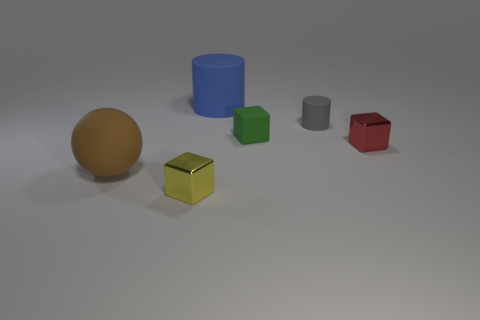Add 2 shiny cubes. How many objects exist? 8 Subtract all cylinders. How many objects are left? 4 Add 1 tiny yellow things. How many tiny yellow things exist? 2 Subtract 1 gray cylinders. How many objects are left? 5 Subtract all brown objects. Subtract all large brown matte balls. How many objects are left? 4 Add 2 brown objects. How many brown objects are left? 3 